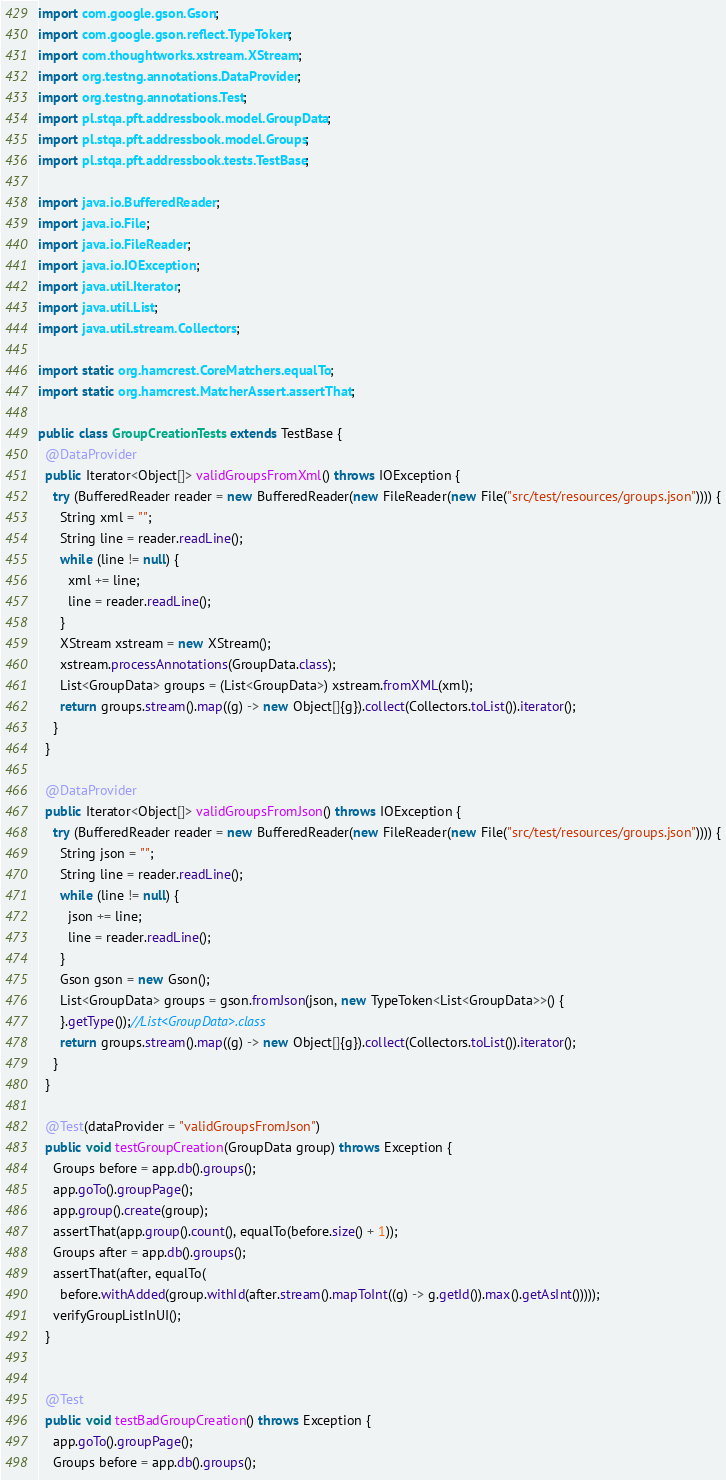<code> <loc_0><loc_0><loc_500><loc_500><_Java_>import com.google.gson.Gson;
import com.google.gson.reflect.TypeToken;
import com.thoughtworks.xstream.XStream;
import org.testng.annotations.DataProvider;
import org.testng.annotations.Test;
import pl.stqa.pft.addressbook.model.GroupData;
import pl.stqa.pft.addressbook.model.Groups;
import pl.stqa.pft.addressbook.tests.TestBase;

import java.io.BufferedReader;
import java.io.File;
import java.io.FileReader;
import java.io.IOException;
import java.util.Iterator;
import java.util.List;
import java.util.stream.Collectors;

import static org.hamcrest.CoreMatchers.equalTo;
import static org.hamcrest.MatcherAssert.assertThat;

public class GroupCreationTests extends TestBase {
  @DataProvider
  public Iterator<Object[]> validGroupsFromXml() throws IOException {
    try (BufferedReader reader = new BufferedReader(new FileReader(new File("src/test/resources/groups.json")))) {
      String xml = "";
      String line = reader.readLine();
      while (line != null) {
        xml += line;
        line = reader.readLine();
      }
      XStream xstream = new XStream();
      xstream.processAnnotations(GroupData.class);
      List<GroupData> groups = (List<GroupData>) xstream.fromXML(xml);
      return groups.stream().map((g) -> new Object[]{g}).collect(Collectors.toList()).iterator();
    }
  }

  @DataProvider
  public Iterator<Object[]> validGroupsFromJson() throws IOException {
    try (BufferedReader reader = new BufferedReader(new FileReader(new File("src/test/resources/groups.json")))) {
      String json = "";
      String line = reader.readLine();
      while (line != null) {
        json += line;
        line = reader.readLine();
      }
      Gson gson = new Gson();
      List<GroupData> groups = gson.fromJson(json, new TypeToken<List<GroupData>>() {
      }.getType());//List<GroupData>.class
      return groups.stream().map((g) -> new Object[]{g}).collect(Collectors.toList()).iterator();
    }
  }

  @Test(dataProvider = "validGroupsFromJson")
  public void testGroupCreation(GroupData group) throws Exception {
    Groups before = app.db().groups();
    app.goTo().groupPage();
    app.group().create(group);
    assertThat(app.group().count(), equalTo(before.size() + 1));
    Groups after = app.db().groups();
    assertThat(after, equalTo(
      before.withAdded(group.withId(after.stream().mapToInt((g) -> g.getId()).max().getAsInt()))));
    verifyGroupListInUI();
  }


  @Test
  public void testBadGroupCreation() throws Exception {
    app.goTo().groupPage();
    Groups before = app.db().groups();</code> 